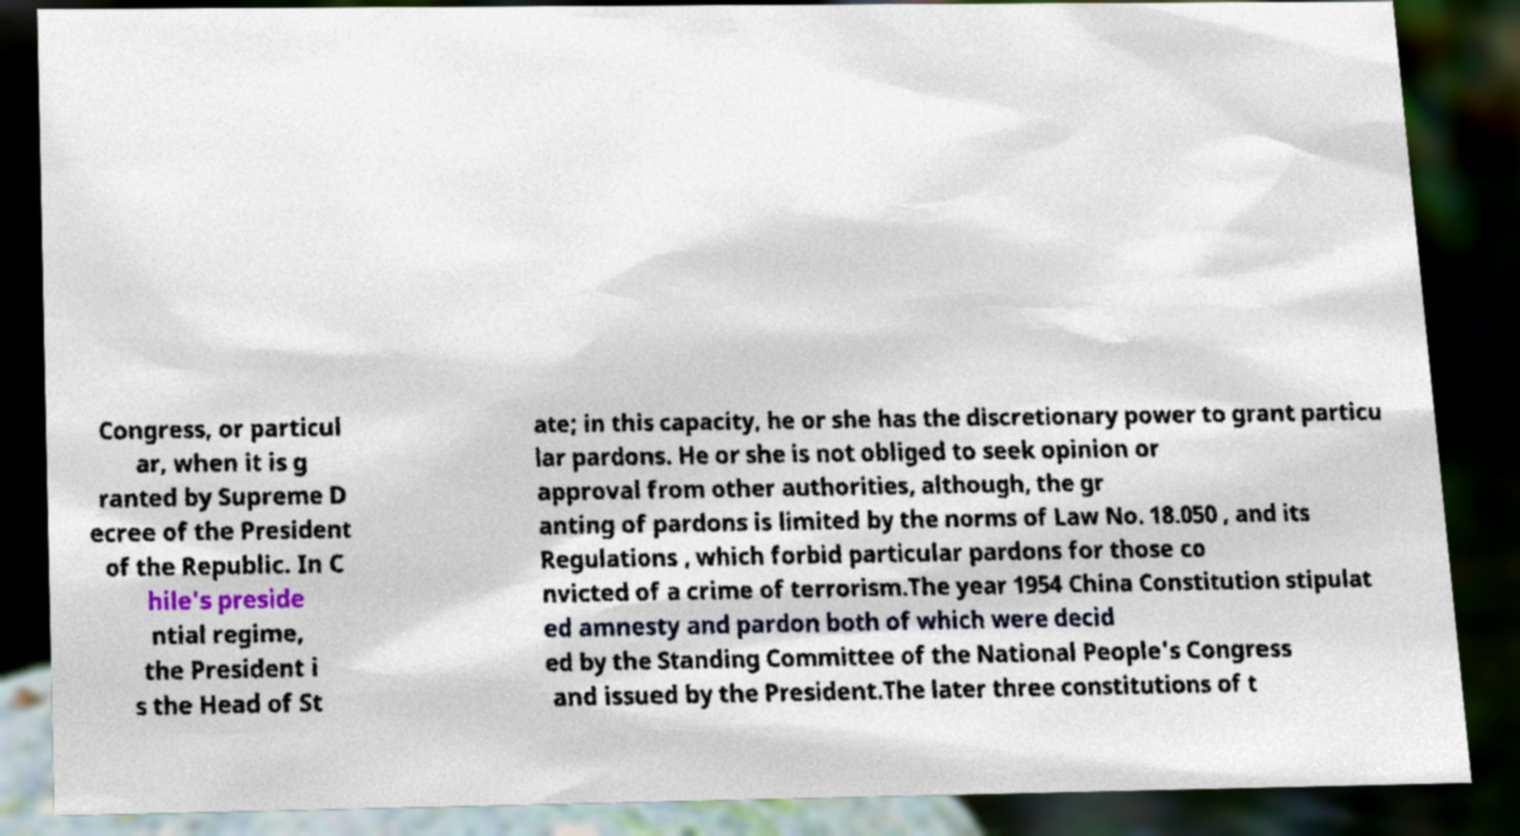What messages or text are displayed in this image? I need them in a readable, typed format. Congress, or particul ar, when it is g ranted by Supreme D ecree of the President of the Republic. In C hile's preside ntial regime, the President i s the Head of St ate; in this capacity, he or she has the discretionary power to grant particu lar pardons. He or she is not obliged to seek opinion or approval from other authorities, although, the gr anting of pardons is limited by the norms of Law No. 18.050 , and its Regulations , which forbid particular pardons for those co nvicted of a crime of terrorism.The year 1954 China Constitution stipulat ed amnesty and pardon both of which were decid ed by the Standing Committee of the National People's Congress and issued by the President.The later three constitutions of t 